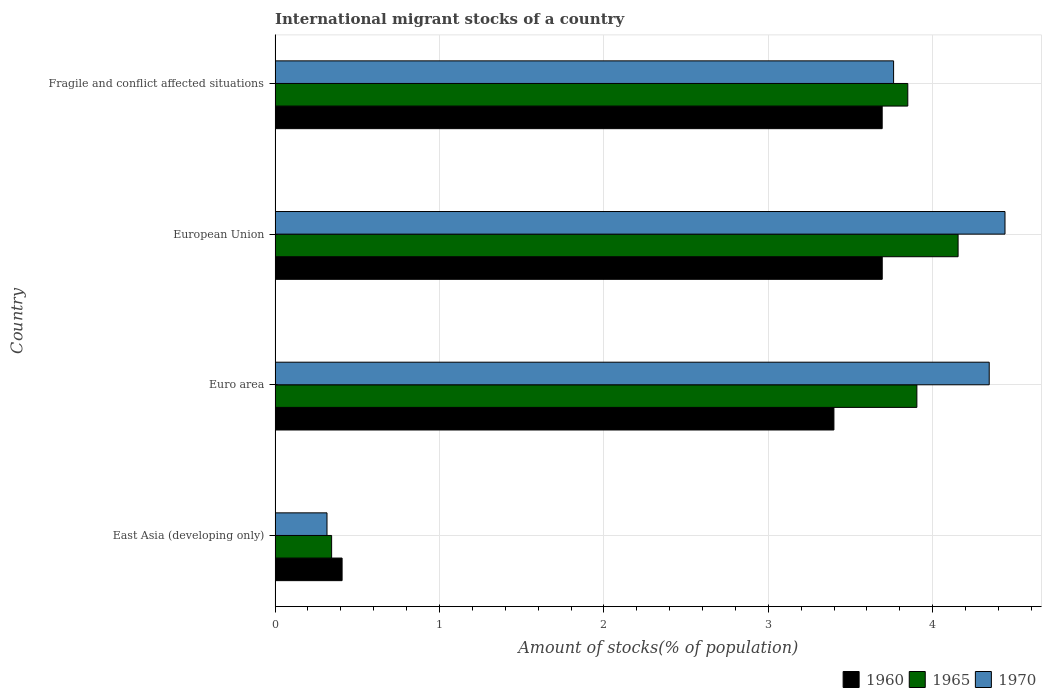How many different coloured bars are there?
Ensure brevity in your answer.  3. Are the number of bars per tick equal to the number of legend labels?
Make the answer very short. Yes. How many bars are there on the 1st tick from the top?
Provide a succinct answer. 3. What is the label of the 1st group of bars from the top?
Offer a very short reply. Fragile and conflict affected situations. What is the amount of stocks in in 1965 in East Asia (developing only)?
Provide a succinct answer. 0.34. Across all countries, what is the maximum amount of stocks in in 1960?
Provide a short and direct response. 3.69. Across all countries, what is the minimum amount of stocks in in 1960?
Offer a very short reply. 0.41. In which country was the amount of stocks in in 1970 minimum?
Ensure brevity in your answer.  East Asia (developing only). What is the total amount of stocks in in 1960 in the graph?
Keep it short and to the point. 11.19. What is the difference between the amount of stocks in in 1965 in European Union and that in Fragile and conflict affected situations?
Provide a succinct answer. 0.31. What is the difference between the amount of stocks in in 1965 in European Union and the amount of stocks in in 1960 in East Asia (developing only)?
Provide a short and direct response. 3.75. What is the average amount of stocks in in 1965 per country?
Give a very brief answer. 3.06. What is the difference between the amount of stocks in in 1965 and amount of stocks in in 1960 in Fragile and conflict affected situations?
Offer a very short reply. 0.16. What is the ratio of the amount of stocks in in 1970 in East Asia (developing only) to that in Fragile and conflict affected situations?
Your response must be concise. 0.08. Is the amount of stocks in in 1965 in East Asia (developing only) less than that in European Union?
Your response must be concise. Yes. What is the difference between the highest and the second highest amount of stocks in in 1965?
Offer a very short reply. 0.25. What is the difference between the highest and the lowest amount of stocks in in 1960?
Offer a terse response. 3.29. In how many countries, is the amount of stocks in in 1960 greater than the average amount of stocks in in 1960 taken over all countries?
Offer a very short reply. 3. Is the sum of the amount of stocks in in 1970 in East Asia (developing only) and European Union greater than the maximum amount of stocks in in 1965 across all countries?
Give a very brief answer. Yes. What does the 3rd bar from the top in East Asia (developing only) represents?
Provide a succinct answer. 1960. What does the 1st bar from the bottom in East Asia (developing only) represents?
Your answer should be compact. 1960. Is it the case that in every country, the sum of the amount of stocks in in 1960 and amount of stocks in in 1965 is greater than the amount of stocks in in 1970?
Your response must be concise. Yes. Are all the bars in the graph horizontal?
Your answer should be very brief. Yes. What is the difference between two consecutive major ticks on the X-axis?
Provide a short and direct response. 1. Are the values on the major ticks of X-axis written in scientific E-notation?
Provide a short and direct response. No. Does the graph contain any zero values?
Ensure brevity in your answer.  No. Where does the legend appear in the graph?
Ensure brevity in your answer.  Bottom right. How many legend labels are there?
Your answer should be very brief. 3. What is the title of the graph?
Provide a short and direct response. International migrant stocks of a country. What is the label or title of the X-axis?
Offer a very short reply. Amount of stocks(% of population). What is the label or title of the Y-axis?
Offer a very short reply. Country. What is the Amount of stocks(% of population) in 1960 in East Asia (developing only)?
Ensure brevity in your answer.  0.41. What is the Amount of stocks(% of population) of 1965 in East Asia (developing only)?
Provide a short and direct response. 0.34. What is the Amount of stocks(% of population) of 1970 in East Asia (developing only)?
Provide a short and direct response. 0.32. What is the Amount of stocks(% of population) of 1960 in Euro area?
Your answer should be very brief. 3.4. What is the Amount of stocks(% of population) in 1965 in Euro area?
Ensure brevity in your answer.  3.9. What is the Amount of stocks(% of population) in 1970 in Euro area?
Provide a short and direct response. 4.34. What is the Amount of stocks(% of population) in 1960 in European Union?
Offer a terse response. 3.69. What is the Amount of stocks(% of population) in 1965 in European Union?
Give a very brief answer. 4.15. What is the Amount of stocks(% of population) of 1970 in European Union?
Your answer should be compact. 4.44. What is the Amount of stocks(% of population) of 1960 in Fragile and conflict affected situations?
Keep it short and to the point. 3.69. What is the Amount of stocks(% of population) of 1965 in Fragile and conflict affected situations?
Make the answer very short. 3.85. What is the Amount of stocks(% of population) in 1970 in Fragile and conflict affected situations?
Give a very brief answer. 3.76. Across all countries, what is the maximum Amount of stocks(% of population) of 1960?
Offer a terse response. 3.69. Across all countries, what is the maximum Amount of stocks(% of population) in 1965?
Keep it short and to the point. 4.15. Across all countries, what is the maximum Amount of stocks(% of population) in 1970?
Your answer should be compact. 4.44. Across all countries, what is the minimum Amount of stocks(% of population) in 1960?
Provide a short and direct response. 0.41. Across all countries, what is the minimum Amount of stocks(% of population) in 1965?
Keep it short and to the point. 0.34. Across all countries, what is the minimum Amount of stocks(% of population) in 1970?
Offer a terse response. 0.32. What is the total Amount of stocks(% of population) in 1960 in the graph?
Your answer should be very brief. 11.19. What is the total Amount of stocks(% of population) in 1965 in the graph?
Your answer should be compact. 12.25. What is the total Amount of stocks(% of population) in 1970 in the graph?
Provide a short and direct response. 12.86. What is the difference between the Amount of stocks(% of population) in 1960 in East Asia (developing only) and that in Euro area?
Offer a very short reply. -2.99. What is the difference between the Amount of stocks(% of population) of 1965 in East Asia (developing only) and that in Euro area?
Offer a very short reply. -3.56. What is the difference between the Amount of stocks(% of population) of 1970 in East Asia (developing only) and that in Euro area?
Offer a terse response. -4.03. What is the difference between the Amount of stocks(% of population) of 1960 in East Asia (developing only) and that in European Union?
Your response must be concise. -3.29. What is the difference between the Amount of stocks(% of population) of 1965 in East Asia (developing only) and that in European Union?
Give a very brief answer. -3.81. What is the difference between the Amount of stocks(% of population) in 1970 in East Asia (developing only) and that in European Union?
Provide a short and direct response. -4.12. What is the difference between the Amount of stocks(% of population) in 1960 in East Asia (developing only) and that in Fragile and conflict affected situations?
Make the answer very short. -3.29. What is the difference between the Amount of stocks(% of population) of 1965 in East Asia (developing only) and that in Fragile and conflict affected situations?
Offer a very short reply. -3.5. What is the difference between the Amount of stocks(% of population) in 1970 in East Asia (developing only) and that in Fragile and conflict affected situations?
Ensure brevity in your answer.  -3.45. What is the difference between the Amount of stocks(% of population) in 1960 in Euro area and that in European Union?
Offer a terse response. -0.29. What is the difference between the Amount of stocks(% of population) in 1965 in Euro area and that in European Union?
Make the answer very short. -0.25. What is the difference between the Amount of stocks(% of population) of 1970 in Euro area and that in European Union?
Keep it short and to the point. -0.1. What is the difference between the Amount of stocks(% of population) in 1960 in Euro area and that in Fragile and conflict affected situations?
Provide a succinct answer. -0.29. What is the difference between the Amount of stocks(% of population) of 1965 in Euro area and that in Fragile and conflict affected situations?
Give a very brief answer. 0.06. What is the difference between the Amount of stocks(% of population) of 1970 in Euro area and that in Fragile and conflict affected situations?
Give a very brief answer. 0.58. What is the difference between the Amount of stocks(% of population) of 1960 in European Union and that in Fragile and conflict affected situations?
Give a very brief answer. 0. What is the difference between the Amount of stocks(% of population) in 1965 in European Union and that in Fragile and conflict affected situations?
Offer a very short reply. 0.31. What is the difference between the Amount of stocks(% of population) of 1970 in European Union and that in Fragile and conflict affected situations?
Offer a very short reply. 0.68. What is the difference between the Amount of stocks(% of population) of 1960 in East Asia (developing only) and the Amount of stocks(% of population) of 1965 in Euro area?
Offer a very short reply. -3.5. What is the difference between the Amount of stocks(% of population) in 1960 in East Asia (developing only) and the Amount of stocks(% of population) in 1970 in Euro area?
Keep it short and to the point. -3.94. What is the difference between the Amount of stocks(% of population) of 1965 in East Asia (developing only) and the Amount of stocks(% of population) of 1970 in Euro area?
Offer a very short reply. -4. What is the difference between the Amount of stocks(% of population) of 1960 in East Asia (developing only) and the Amount of stocks(% of population) of 1965 in European Union?
Offer a terse response. -3.75. What is the difference between the Amount of stocks(% of population) in 1960 in East Asia (developing only) and the Amount of stocks(% of population) in 1970 in European Union?
Your answer should be very brief. -4.03. What is the difference between the Amount of stocks(% of population) of 1965 in East Asia (developing only) and the Amount of stocks(% of population) of 1970 in European Union?
Offer a very short reply. -4.1. What is the difference between the Amount of stocks(% of population) in 1960 in East Asia (developing only) and the Amount of stocks(% of population) in 1965 in Fragile and conflict affected situations?
Your answer should be very brief. -3.44. What is the difference between the Amount of stocks(% of population) in 1960 in East Asia (developing only) and the Amount of stocks(% of population) in 1970 in Fragile and conflict affected situations?
Offer a terse response. -3.35. What is the difference between the Amount of stocks(% of population) of 1965 in East Asia (developing only) and the Amount of stocks(% of population) of 1970 in Fragile and conflict affected situations?
Provide a short and direct response. -3.42. What is the difference between the Amount of stocks(% of population) of 1960 in Euro area and the Amount of stocks(% of population) of 1965 in European Union?
Your answer should be very brief. -0.76. What is the difference between the Amount of stocks(% of population) in 1960 in Euro area and the Amount of stocks(% of population) in 1970 in European Union?
Your response must be concise. -1.04. What is the difference between the Amount of stocks(% of population) in 1965 in Euro area and the Amount of stocks(% of population) in 1970 in European Union?
Provide a short and direct response. -0.54. What is the difference between the Amount of stocks(% of population) of 1960 in Euro area and the Amount of stocks(% of population) of 1965 in Fragile and conflict affected situations?
Your answer should be compact. -0.45. What is the difference between the Amount of stocks(% of population) in 1960 in Euro area and the Amount of stocks(% of population) in 1970 in Fragile and conflict affected situations?
Your answer should be compact. -0.36. What is the difference between the Amount of stocks(% of population) in 1965 in Euro area and the Amount of stocks(% of population) in 1970 in Fragile and conflict affected situations?
Give a very brief answer. 0.14. What is the difference between the Amount of stocks(% of population) in 1960 in European Union and the Amount of stocks(% of population) in 1965 in Fragile and conflict affected situations?
Offer a terse response. -0.16. What is the difference between the Amount of stocks(% of population) of 1960 in European Union and the Amount of stocks(% of population) of 1970 in Fragile and conflict affected situations?
Make the answer very short. -0.07. What is the difference between the Amount of stocks(% of population) of 1965 in European Union and the Amount of stocks(% of population) of 1970 in Fragile and conflict affected situations?
Your answer should be compact. 0.39. What is the average Amount of stocks(% of population) of 1960 per country?
Offer a terse response. 2.8. What is the average Amount of stocks(% of population) of 1965 per country?
Keep it short and to the point. 3.06. What is the average Amount of stocks(% of population) of 1970 per country?
Provide a succinct answer. 3.22. What is the difference between the Amount of stocks(% of population) in 1960 and Amount of stocks(% of population) in 1965 in East Asia (developing only)?
Provide a short and direct response. 0.06. What is the difference between the Amount of stocks(% of population) of 1960 and Amount of stocks(% of population) of 1970 in East Asia (developing only)?
Ensure brevity in your answer.  0.09. What is the difference between the Amount of stocks(% of population) in 1965 and Amount of stocks(% of population) in 1970 in East Asia (developing only)?
Provide a short and direct response. 0.03. What is the difference between the Amount of stocks(% of population) in 1960 and Amount of stocks(% of population) in 1965 in Euro area?
Ensure brevity in your answer.  -0.5. What is the difference between the Amount of stocks(% of population) in 1960 and Amount of stocks(% of population) in 1970 in Euro area?
Provide a succinct answer. -0.94. What is the difference between the Amount of stocks(% of population) of 1965 and Amount of stocks(% of population) of 1970 in Euro area?
Provide a succinct answer. -0.44. What is the difference between the Amount of stocks(% of population) of 1960 and Amount of stocks(% of population) of 1965 in European Union?
Offer a terse response. -0.46. What is the difference between the Amount of stocks(% of population) in 1960 and Amount of stocks(% of population) in 1970 in European Union?
Keep it short and to the point. -0.75. What is the difference between the Amount of stocks(% of population) in 1965 and Amount of stocks(% of population) in 1970 in European Union?
Offer a very short reply. -0.29. What is the difference between the Amount of stocks(% of population) in 1960 and Amount of stocks(% of population) in 1965 in Fragile and conflict affected situations?
Your answer should be compact. -0.16. What is the difference between the Amount of stocks(% of population) of 1960 and Amount of stocks(% of population) of 1970 in Fragile and conflict affected situations?
Make the answer very short. -0.07. What is the difference between the Amount of stocks(% of population) of 1965 and Amount of stocks(% of population) of 1970 in Fragile and conflict affected situations?
Keep it short and to the point. 0.09. What is the ratio of the Amount of stocks(% of population) in 1960 in East Asia (developing only) to that in Euro area?
Your answer should be very brief. 0.12. What is the ratio of the Amount of stocks(% of population) in 1965 in East Asia (developing only) to that in Euro area?
Keep it short and to the point. 0.09. What is the ratio of the Amount of stocks(% of population) of 1970 in East Asia (developing only) to that in Euro area?
Make the answer very short. 0.07. What is the ratio of the Amount of stocks(% of population) of 1960 in East Asia (developing only) to that in European Union?
Provide a short and direct response. 0.11. What is the ratio of the Amount of stocks(% of population) in 1965 in East Asia (developing only) to that in European Union?
Your response must be concise. 0.08. What is the ratio of the Amount of stocks(% of population) of 1970 in East Asia (developing only) to that in European Union?
Make the answer very short. 0.07. What is the ratio of the Amount of stocks(% of population) in 1960 in East Asia (developing only) to that in Fragile and conflict affected situations?
Offer a very short reply. 0.11. What is the ratio of the Amount of stocks(% of population) in 1965 in East Asia (developing only) to that in Fragile and conflict affected situations?
Your answer should be compact. 0.09. What is the ratio of the Amount of stocks(% of population) in 1970 in East Asia (developing only) to that in Fragile and conflict affected situations?
Give a very brief answer. 0.08. What is the ratio of the Amount of stocks(% of population) in 1960 in Euro area to that in European Union?
Your answer should be compact. 0.92. What is the ratio of the Amount of stocks(% of population) in 1965 in Euro area to that in European Union?
Give a very brief answer. 0.94. What is the ratio of the Amount of stocks(% of population) of 1970 in Euro area to that in European Union?
Give a very brief answer. 0.98. What is the ratio of the Amount of stocks(% of population) in 1960 in Euro area to that in Fragile and conflict affected situations?
Your answer should be compact. 0.92. What is the ratio of the Amount of stocks(% of population) of 1965 in Euro area to that in Fragile and conflict affected situations?
Offer a terse response. 1.01. What is the ratio of the Amount of stocks(% of population) of 1970 in Euro area to that in Fragile and conflict affected situations?
Your answer should be very brief. 1.15. What is the ratio of the Amount of stocks(% of population) in 1960 in European Union to that in Fragile and conflict affected situations?
Your response must be concise. 1. What is the ratio of the Amount of stocks(% of population) in 1965 in European Union to that in Fragile and conflict affected situations?
Offer a very short reply. 1.08. What is the ratio of the Amount of stocks(% of population) in 1970 in European Union to that in Fragile and conflict affected situations?
Offer a very short reply. 1.18. What is the difference between the highest and the second highest Amount of stocks(% of population) in 1965?
Provide a succinct answer. 0.25. What is the difference between the highest and the second highest Amount of stocks(% of population) of 1970?
Your answer should be very brief. 0.1. What is the difference between the highest and the lowest Amount of stocks(% of population) in 1960?
Provide a short and direct response. 3.29. What is the difference between the highest and the lowest Amount of stocks(% of population) of 1965?
Give a very brief answer. 3.81. What is the difference between the highest and the lowest Amount of stocks(% of population) in 1970?
Provide a short and direct response. 4.12. 